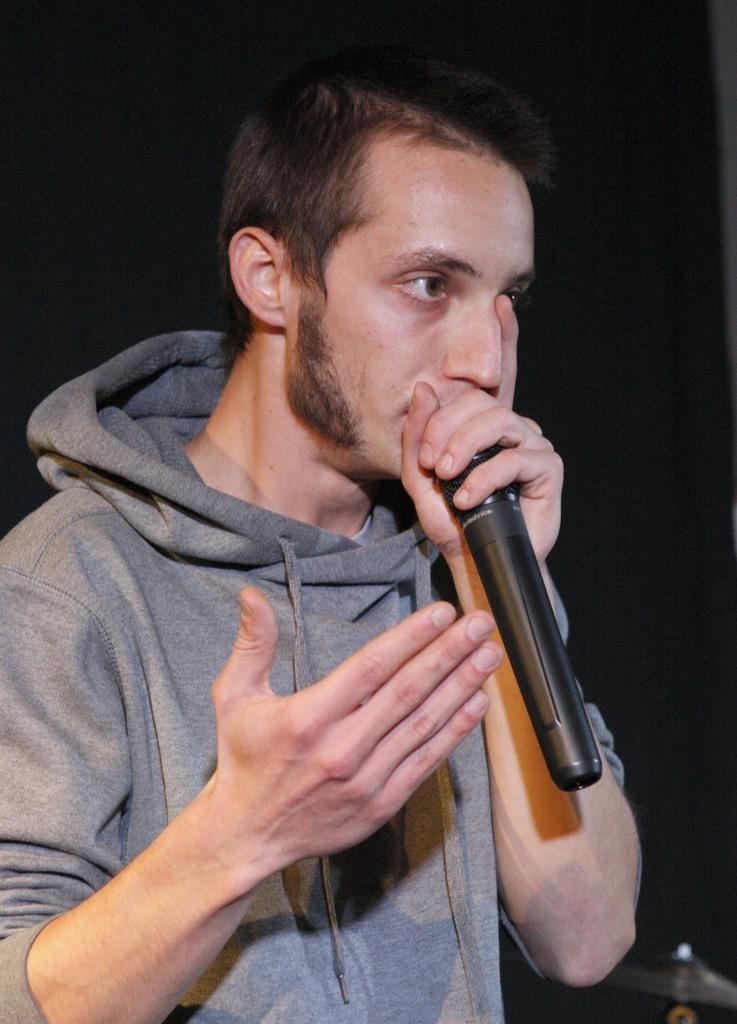Who is present in the image? There is a man in the image. What is the man wearing? The man is wearing clothes. What object is the man holding in his hand? The man is holding a microphone in his hand. What type of ornament is hanging from the man's ear in the image? There is no ornament hanging from the man's ear in the image; he is not wearing any visible jewelry. 